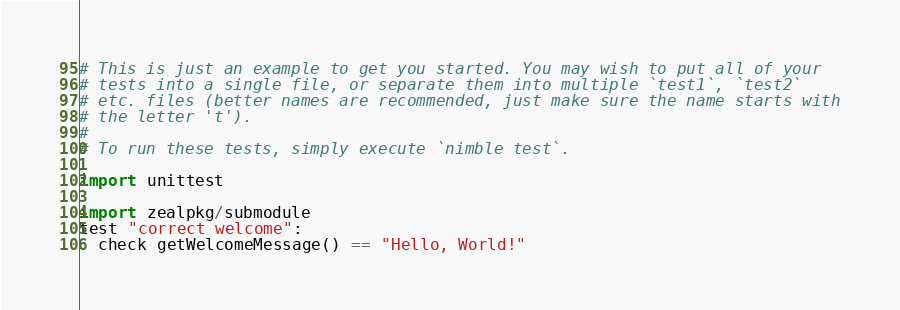Convert code to text. <code><loc_0><loc_0><loc_500><loc_500><_Nim_># This is just an example to get you started. You may wish to put all of your
# tests into a single file, or separate them into multiple `test1`, `test2`
# etc. files (better names are recommended, just make sure the name starts with
# the letter 't').
#
# To run these tests, simply execute `nimble test`.

import unittest

import zealpkg/submodule
test "correct welcome":
  check getWelcomeMessage() == "Hello, World!"
</code> 